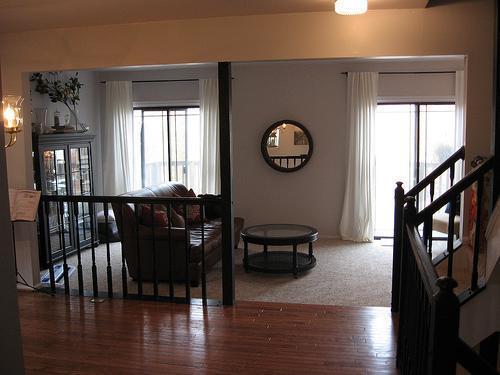How many glass doors are shown?
Give a very brief answer. 2. 